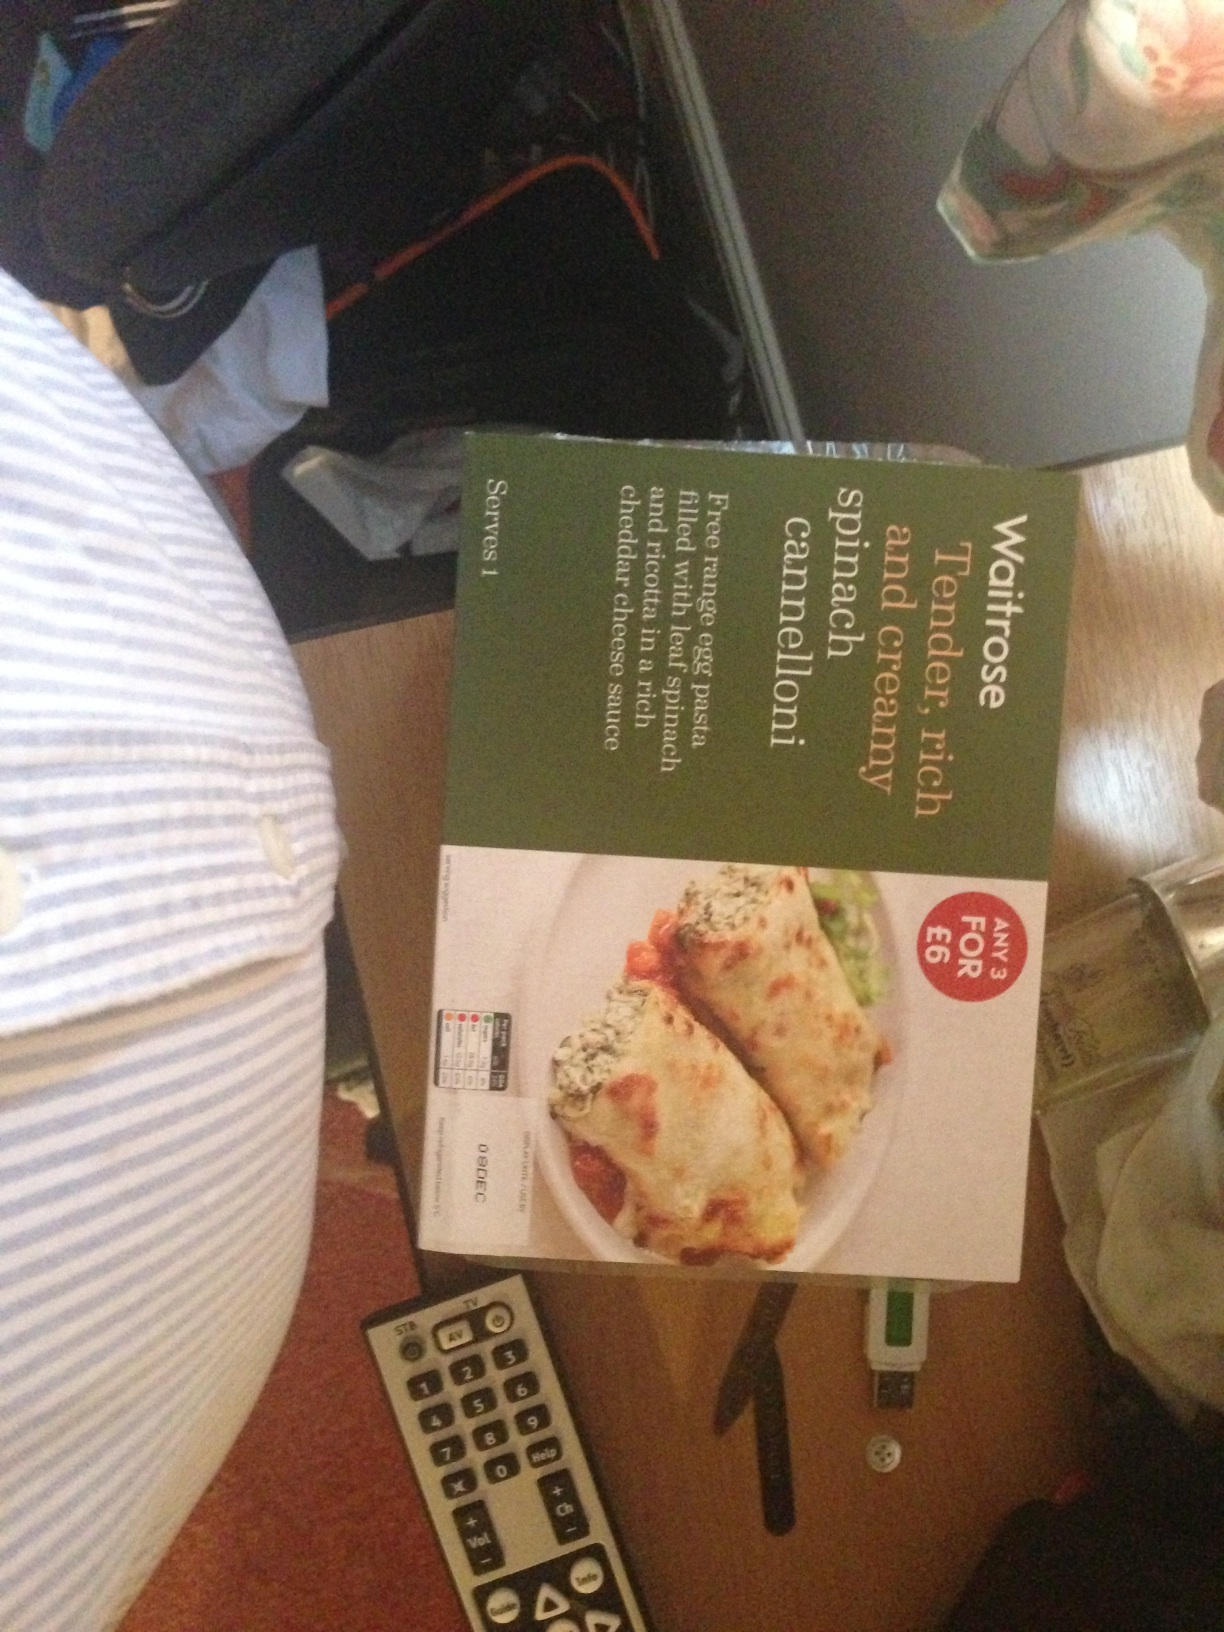Is this meal suitable for vegetarians? The 'Tender, rich spinach cannelloni' from Waitrose appears to be a vegetarian option, as it mainly consists of pasta, spinach, and cheese. However, for strict dietary requirements, it would be best to check the label for any hidden ingredients or potential cross-contamination warnings. 